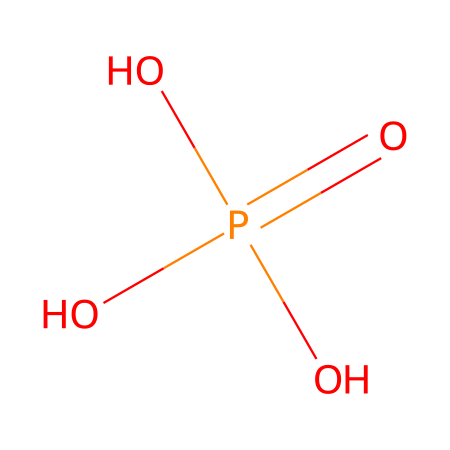What is the main element in this compound? The SMILES representation shows a phosphorus atom (P) surrounded by oxygen atoms (O), indicating that phosphorus is the central element of this compound.
Answer: phosphorus How many oxygen atoms are present in this chemical? The SMILES shows three oxygen atoms (O) surrounding the phosphorus, as indicated by their presence in the structure.
Answer: three Is this compound a component of DNA or RNA? The presence of the phosphate group (indicated by OP(=O)(O)O) is a key characteristic of nucleotides, which are the building blocks of DNA and RNA.
Answer: yes What type of bond connects phosphorus and oxygen in this compound? Phosphorus and oxygen in this structure form covalent bonds, as is typical in phosphates where nonmetal atoms share electrons.
Answer: covalent How many total atoms are present in this chemical? There are one phosphorus and four oxygen atoms, making a total of five atoms in this molecule.
Answer: five What kind of functional group does this compound represent? The OP(=O)(O)O structure identifies it as a phosphate functional group, which is crucial in biochemistry, particularly in nucleic acids.
Answer: phosphate What is the oxidation state of phosphorus in this compound? In this structure, phosphorus has an oxidation state of +5, as indicated by its involvement in four covalent bonds with oxygen.
Answer: +5 